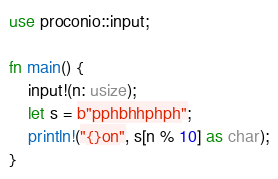Convert code to text. <code><loc_0><loc_0><loc_500><loc_500><_Rust_>use proconio::input;

fn main() {
    input!(n: usize);
    let s = b"pphbhhphph";
    println!("{}on", s[n % 10] as char);
}
</code> 